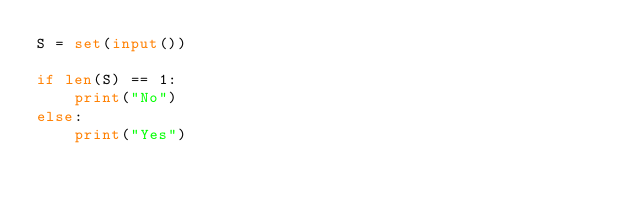Convert code to text. <code><loc_0><loc_0><loc_500><loc_500><_Python_>S = set(input())

if len(S) == 1:
    print("No")
else:
    print("Yes")</code> 